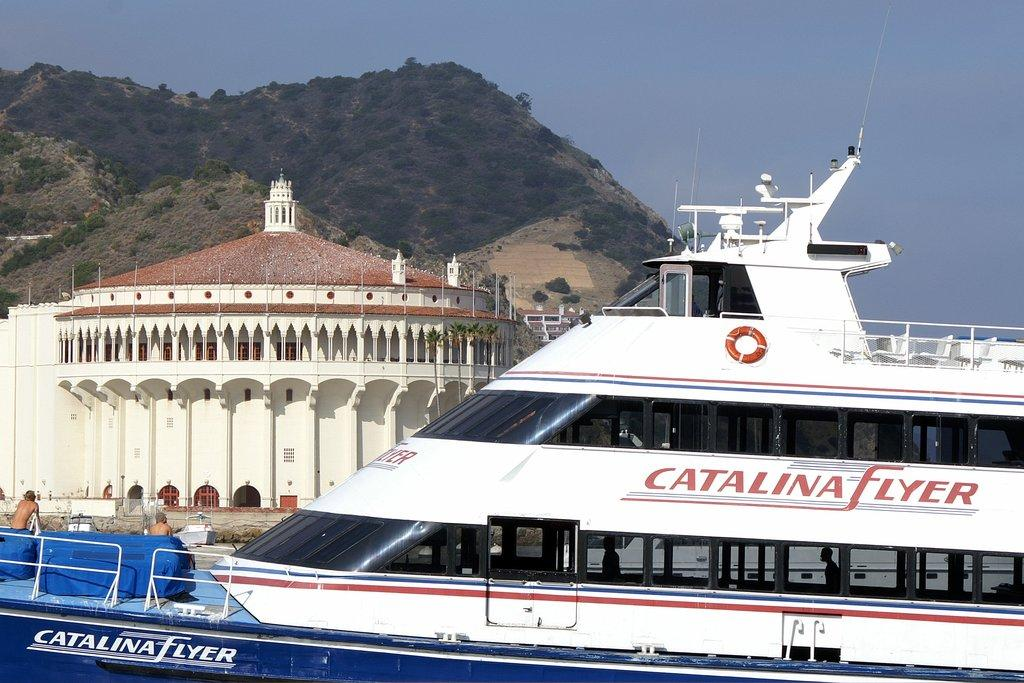What is located on the right side of the image? There is a ship on the right side of the image. What is the color of the ship? The ship is white in color. What is on the left side of the image? There is a house on the left side of the image. What can be seen in the background of the image? In the background, there is a hill. Can you tell me how many yaks are grazing near the house in the image? There are no yaks present in the image; it features a ship on the right side and a house on the left side, with a hill in the background. Is there a judge visible in the image? There is no judge present in the image. 